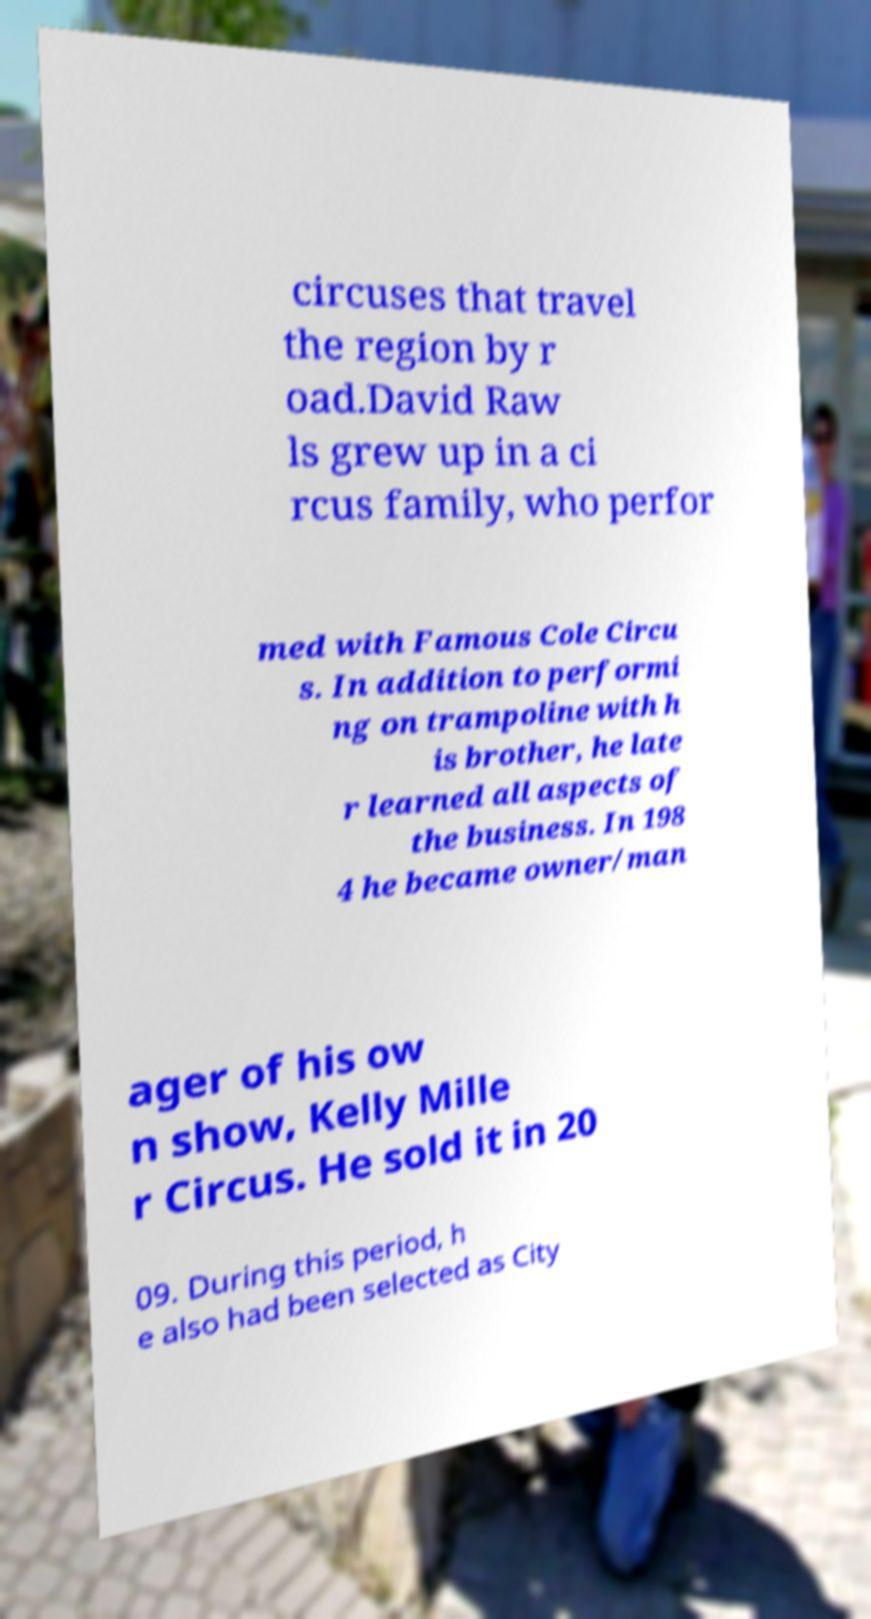Please identify and transcribe the text found in this image. circuses that travel the region by r oad.David Raw ls grew up in a ci rcus family, who perfor med with Famous Cole Circu s. In addition to performi ng on trampoline with h is brother, he late r learned all aspects of the business. In 198 4 he became owner/man ager of his ow n show, Kelly Mille r Circus. He sold it in 20 09. During this period, h e also had been selected as City 